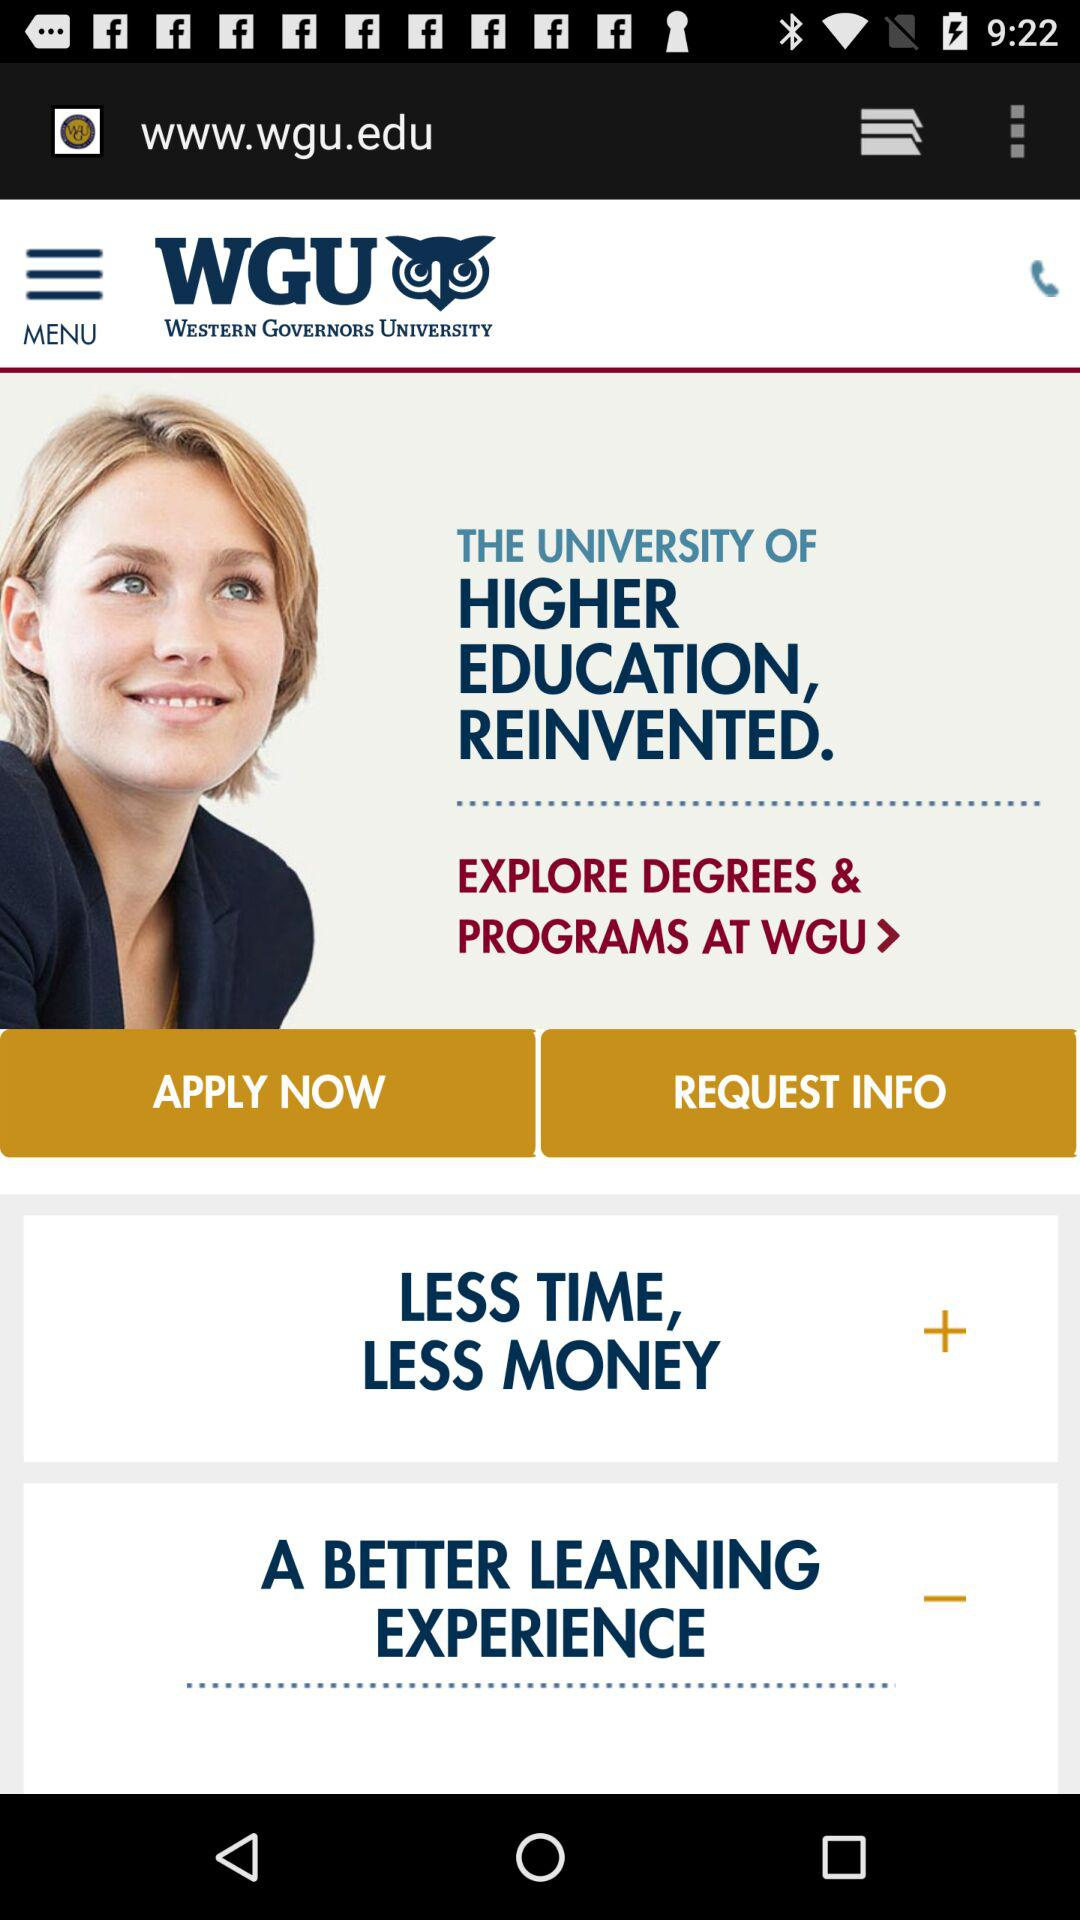What is the application name? The application name is "WESTERN GOVERNORS UNIVERSITY". 